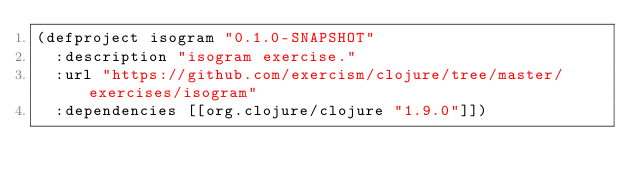<code> <loc_0><loc_0><loc_500><loc_500><_Clojure_>(defproject isogram "0.1.0-SNAPSHOT"
  :description "isogram exercise."
  :url "https://github.com/exercism/clojure/tree/master/exercises/isogram"
  :dependencies [[org.clojure/clojure "1.9.0"]])
</code> 